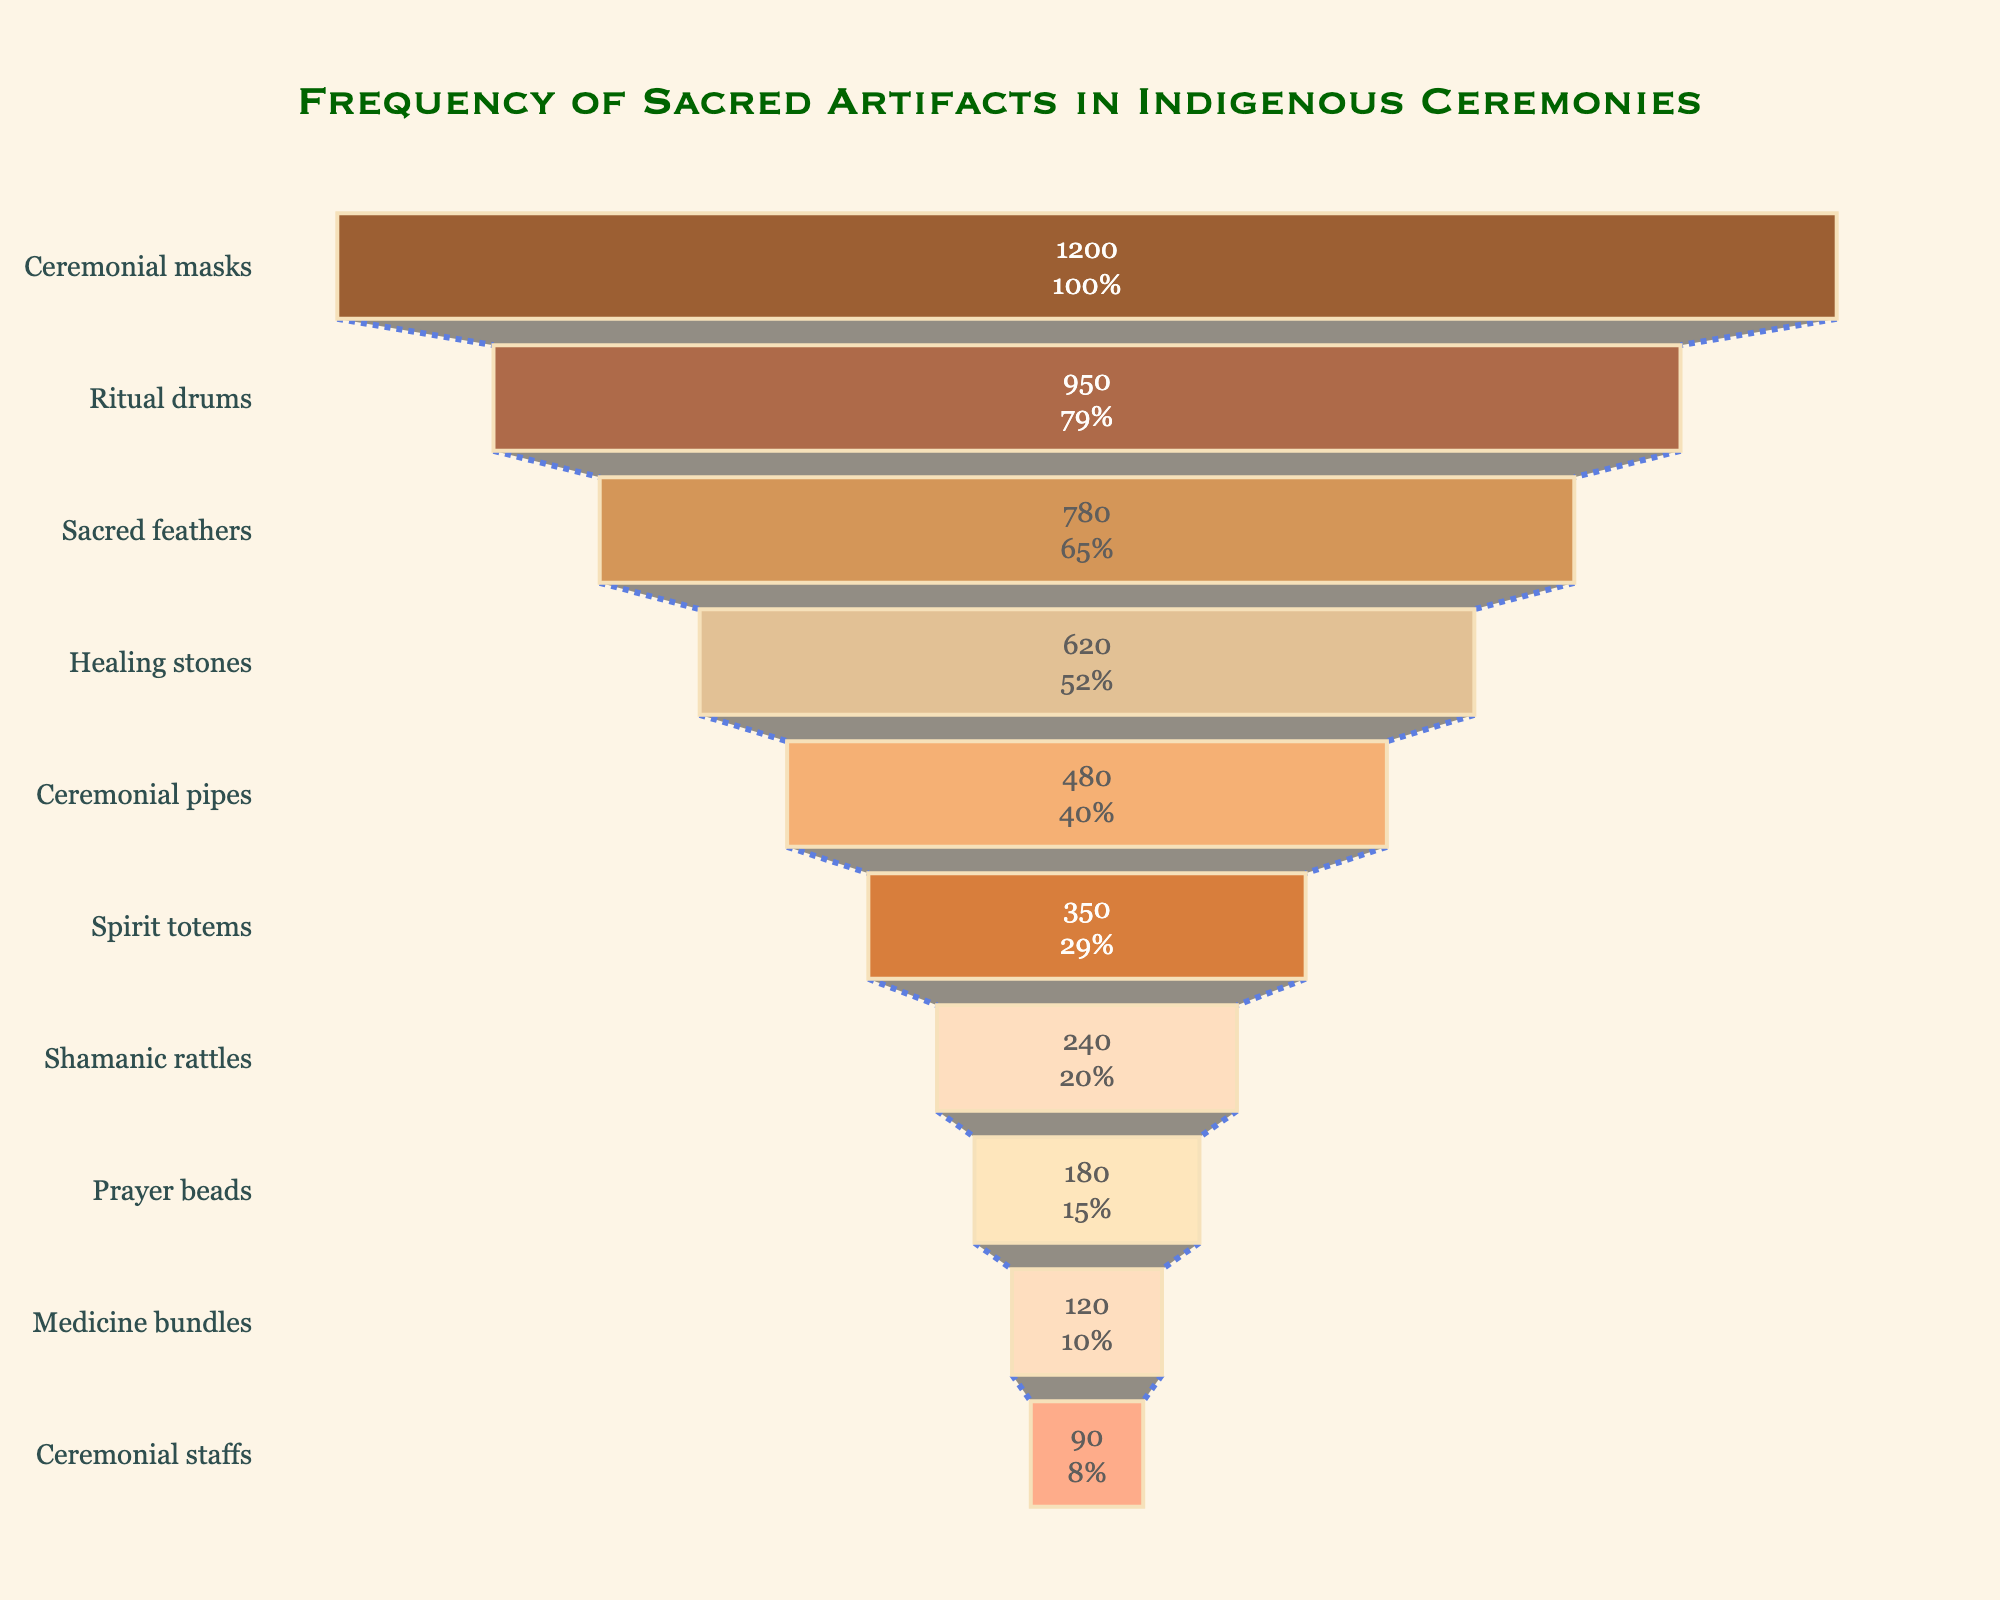What is the most common type of sacred artifact used in indigenous ceremonies? The topmost position in a funnel chart typically represents the highest frequency. Here, the artifact type at the top is "Ceremonial masks" with 1200 instances.
Answer: Ceremonial masks Which sacred artifact has the lowest frequency? The bottom position in a funnel chart represents the lowest frequency. Here, it is "Ceremonial staffs" with 90 instances.
Answer: Ceremonial staffs By how much does the frequency of ritual drums exceed that of ceremonial pipes? The frequency of ritual drums is 950 and that of ceremonial pipes is 480. The difference is calculated as 950 - 480.
Answer: 470 What is the cumulative frequency of spirit totems, shamanic rattles, and prayer beads? Adding the frequencies of these artifacts: 350 (spirit totems) + 240 (shamanic rattles) + 180 (prayer beads) = 770.
Answer: 770 How many artifact types have a frequency greater than 600? Observing the funnel chart, we see that there are 4 types: Ceremonial masks (1200), Ritual drums (950), Sacred feathers (780), and Healing stones (620).
Answer: 4 Which artifact types have a frequency between 200 and 500? Only the "Ceremonial pipes" and "Spirit totems" fall in this range with frequencies of 480 and 350, respectively.
Answer: Ceremonial pipes, Spirit totems What is the total frequency of all sacred artifacts combined? Adding the frequencies of all artifact types: 1200 + 950 + 780 + 620 + 480 + 350 + 240 + 180 + 120 + 90 = 5010.
Answer: 5010 Which is more common, prayer beads or medicine bundles, and by how much? Prayer beads have a frequency of 180, while medicine bundles have 120. The difference is 180 - 120.
Answer: Prayer beads by 60 Rank the artifact types from most to least frequent. Referencing the funnel chart, the order is: Ceremonial masks, Ritual drums, Sacred feathers, Healing stones, Ceremonial pipes, Spirit totems, Shamanic rattles, Prayer beads, Medicine bundles, and Ceremonial staffs. By frequency, the list is: 1200, 950, 780, 620, 480, 350, 240, 180, 120, 90.
Answer: Ceremonial masks, Ritual drums, Sacred feathers, Healing stones, Ceremonial pipes, Spirit totems, Shamanic rattles, Prayer beads, Medicine bundles, Ceremonial staffs What percentage of the total frequency is represented by ceremonial masks? The frequency of ceremonial masks is 1200. The total frequency is 5010. The percentage is calculated as (1200 / 5010) * 100 ≈ 23.95%.
Answer: 23.95% 